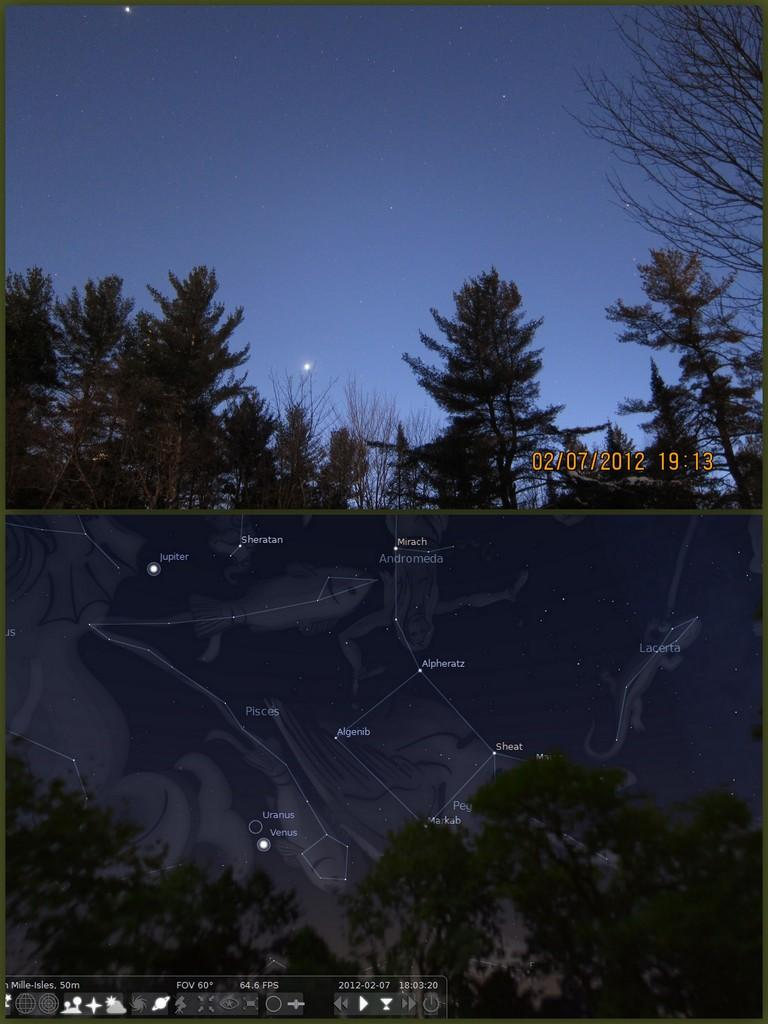What is the main subject of the image? There is a collage in the image. What type of natural elements can be seen in the image? There are trees in the image, including a tree that is truncated towards the right side. What part of the sky is visible in the image? The sky is visible in the image, and it contains stars. What is a part of the collage in the image? There is a graphical image in the collage. What sense is being used to experience the collage in the image? The collage is a visual image, so the sense being used to experience it is sight. What type of field is visible in the image? There is no field visible in the image; it features a collage with trees, a truncated tree, the sky, stars, and a graphical image within the collage. 